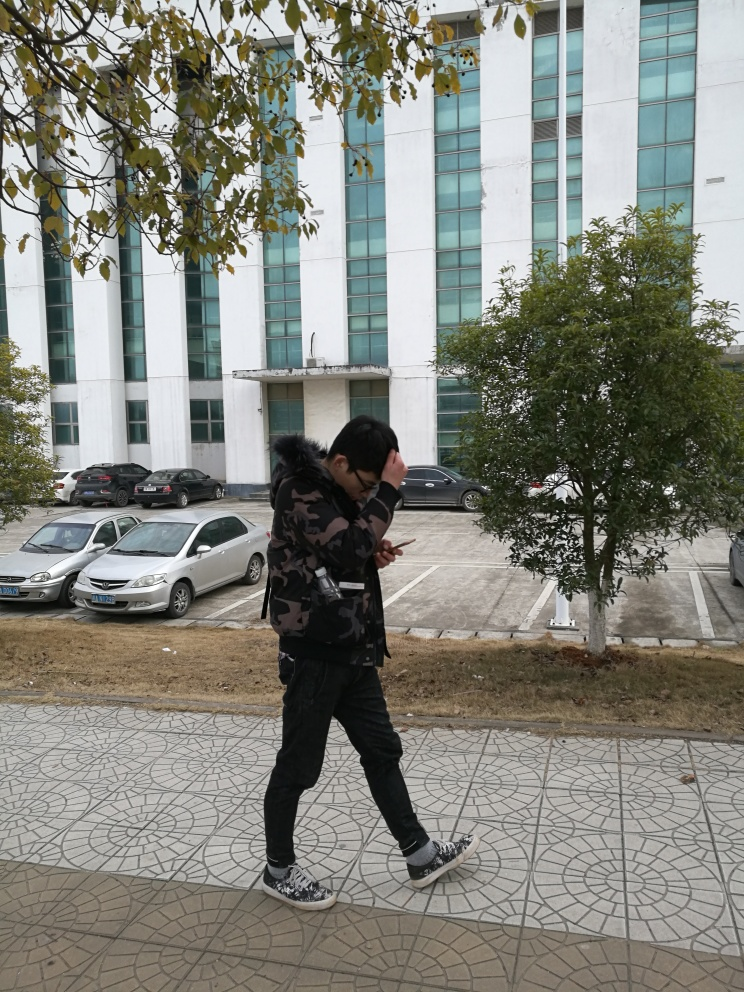Can you describe the style of walking of the person in the image? The person appears to be walking purposefully with a slightly leaned-forward posture, possibly indicating haste or an intent to quickly reach a destination. What does the person's attire suggest about their possible activities or destination? The individual is dressed in casual streetwear with a camouflage pattern jacket and sneakers, which might imply a casual outing or a social meeting, rather than a formal event. 